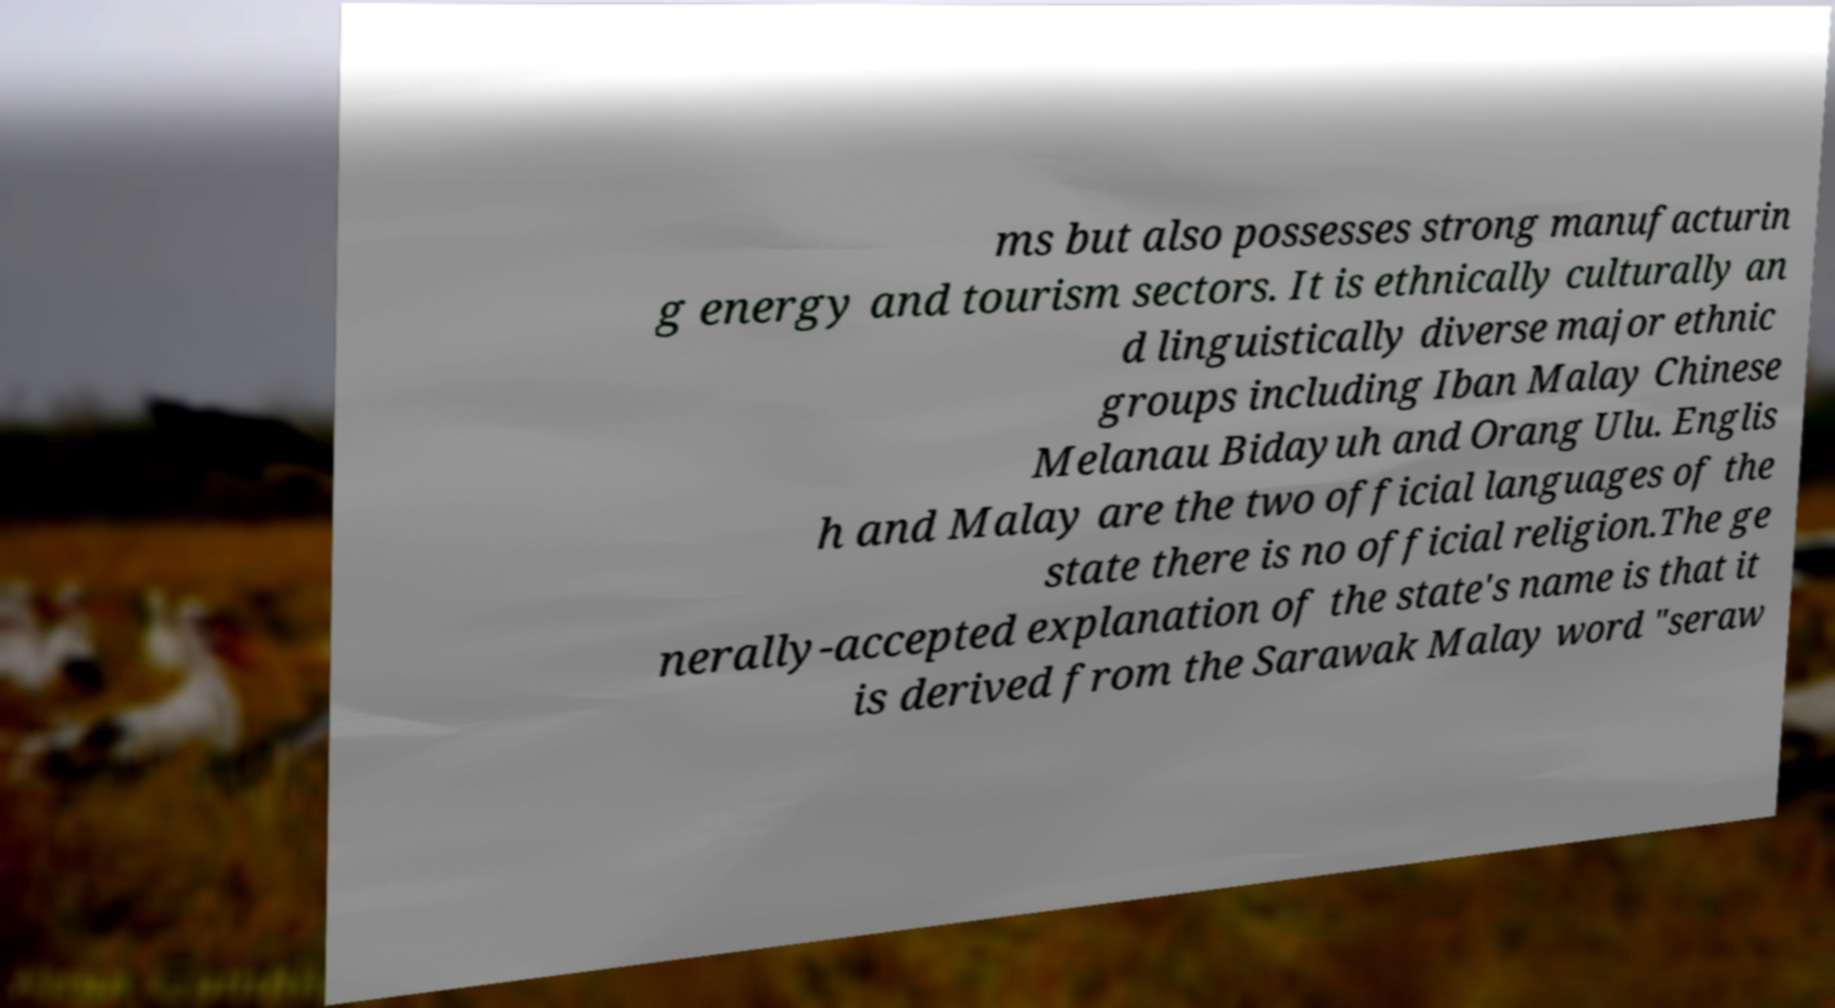Could you assist in decoding the text presented in this image and type it out clearly? ms but also possesses strong manufacturin g energy and tourism sectors. It is ethnically culturally an d linguistically diverse major ethnic groups including Iban Malay Chinese Melanau Bidayuh and Orang Ulu. Englis h and Malay are the two official languages of the state there is no official religion.The ge nerally-accepted explanation of the state's name is that it is derived from the Sarawak Malay word "seraw 